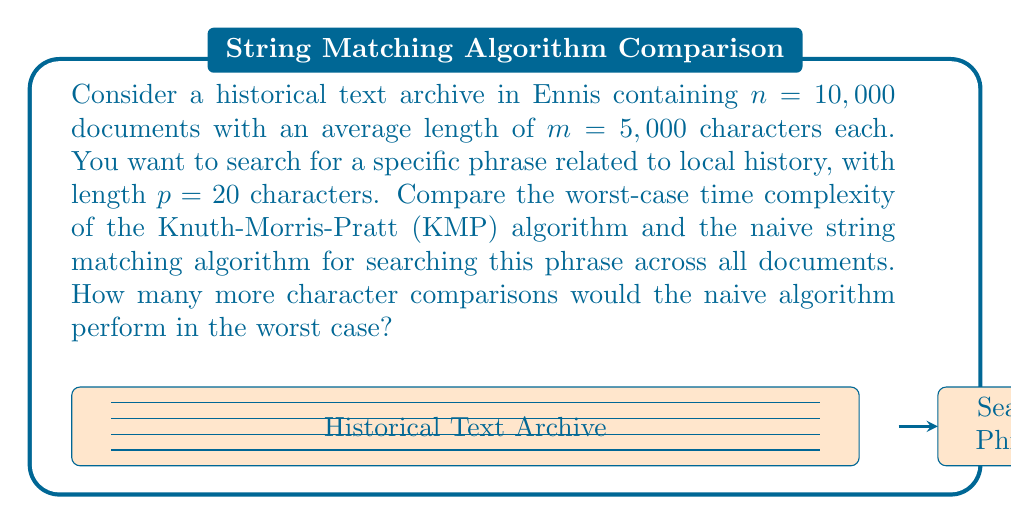Can you answer this question? Let's approach this step-by-step:

1) First, we need to calculate the total number of characters in all documents:
   Total characters = $n \times m = 10,000 \times 5,000 = 50,000,000$

2) Naive string matching algorithm:
   - Worst-case time complexity: $O((n \times m) \times p)$
   - Number of comparisons = $50,000,000 \times 20 = 1,000,000,000$

3) Knuth-Morris-Pratt (KMP) algorithm:
   - Worst-case time complexity: $O(n \times m + p)$
   - Number of comparisons ≈ $50,000,000 + 20 \approx 50,000,020$

4) Difference in comparisons:
   $1,000,000,000 - 50,000,020 = 949,999,980$

Therefore, in the worst case, the naive algorithm would perform approximately 950 million more character comparisons than the KMP algorithm.
Answer: 949,999,980 